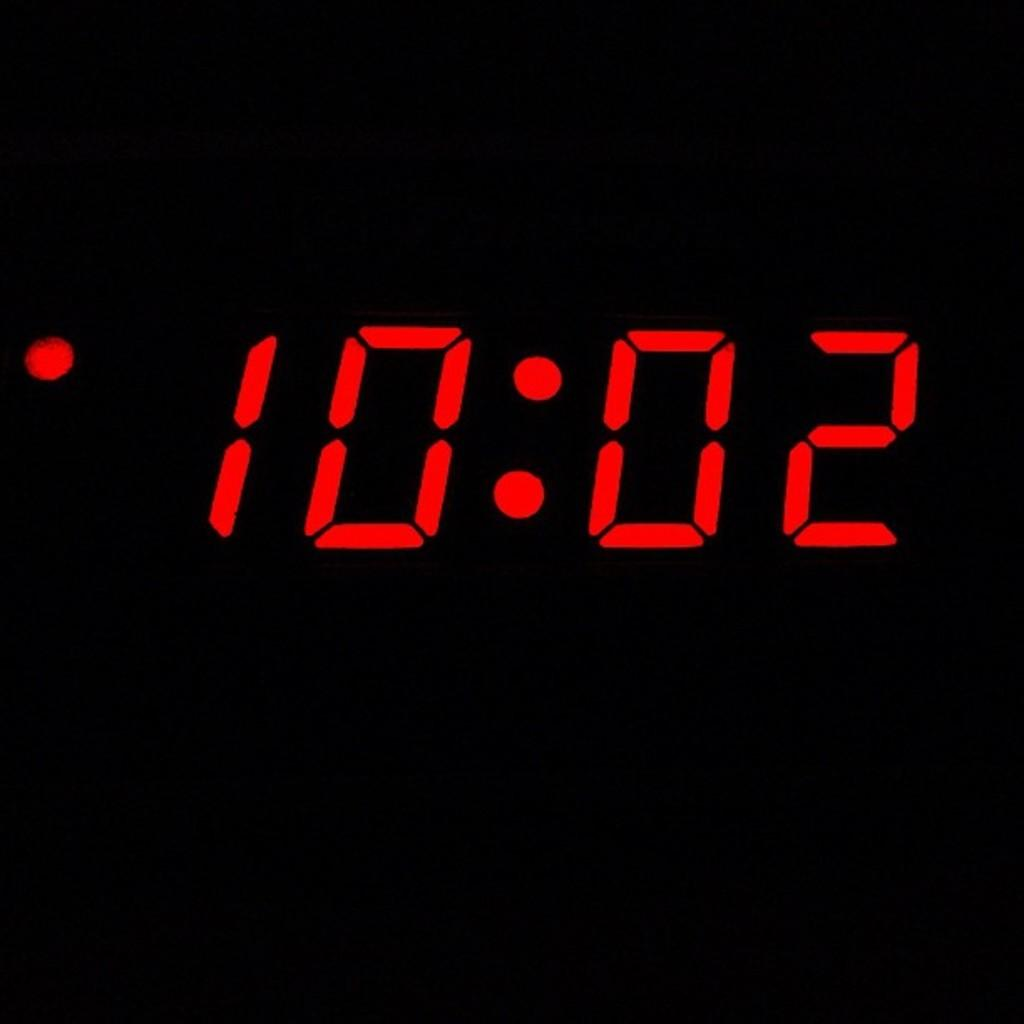<image>
Summarize the visual content of the image. a black clock reads 10:02 in bold red numbers 